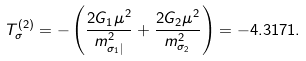Convert formula to latex. <formula><loc_0><loc_0><loc_500><loc_500>T ^ { ( 2 ) } _ { \sigma } = - \left ( \frac { 2 G _ { 1 } \mu ^ { 2 } } { m ^ { 2 } _ { \sigma _ { 1 } | } } + \frac { 2 G _ { 2 } \mu ^ { 2 } } { m ^ { 2 } _ { \sigma _ { 2 } } } \right ) = - 4 . 3 1 7 1 .</formula> 